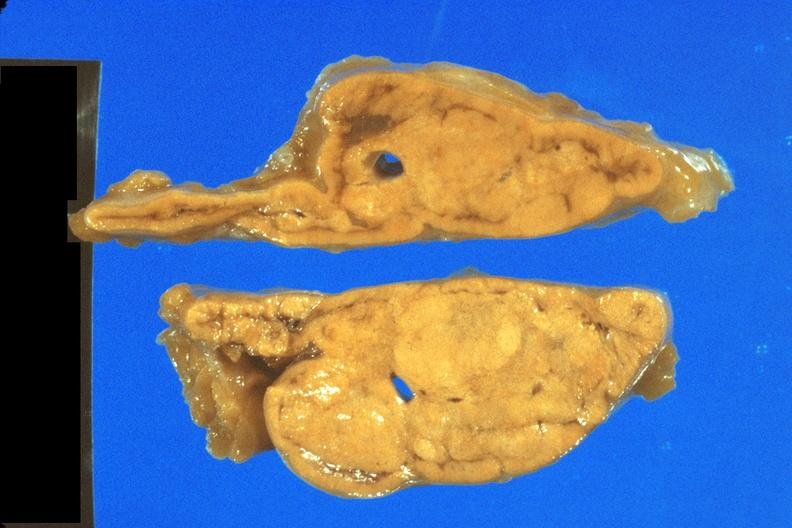does this image show fixed tissue nice close-up view of cortical nodules?
Answer the question using a single word or phrase. Yes 